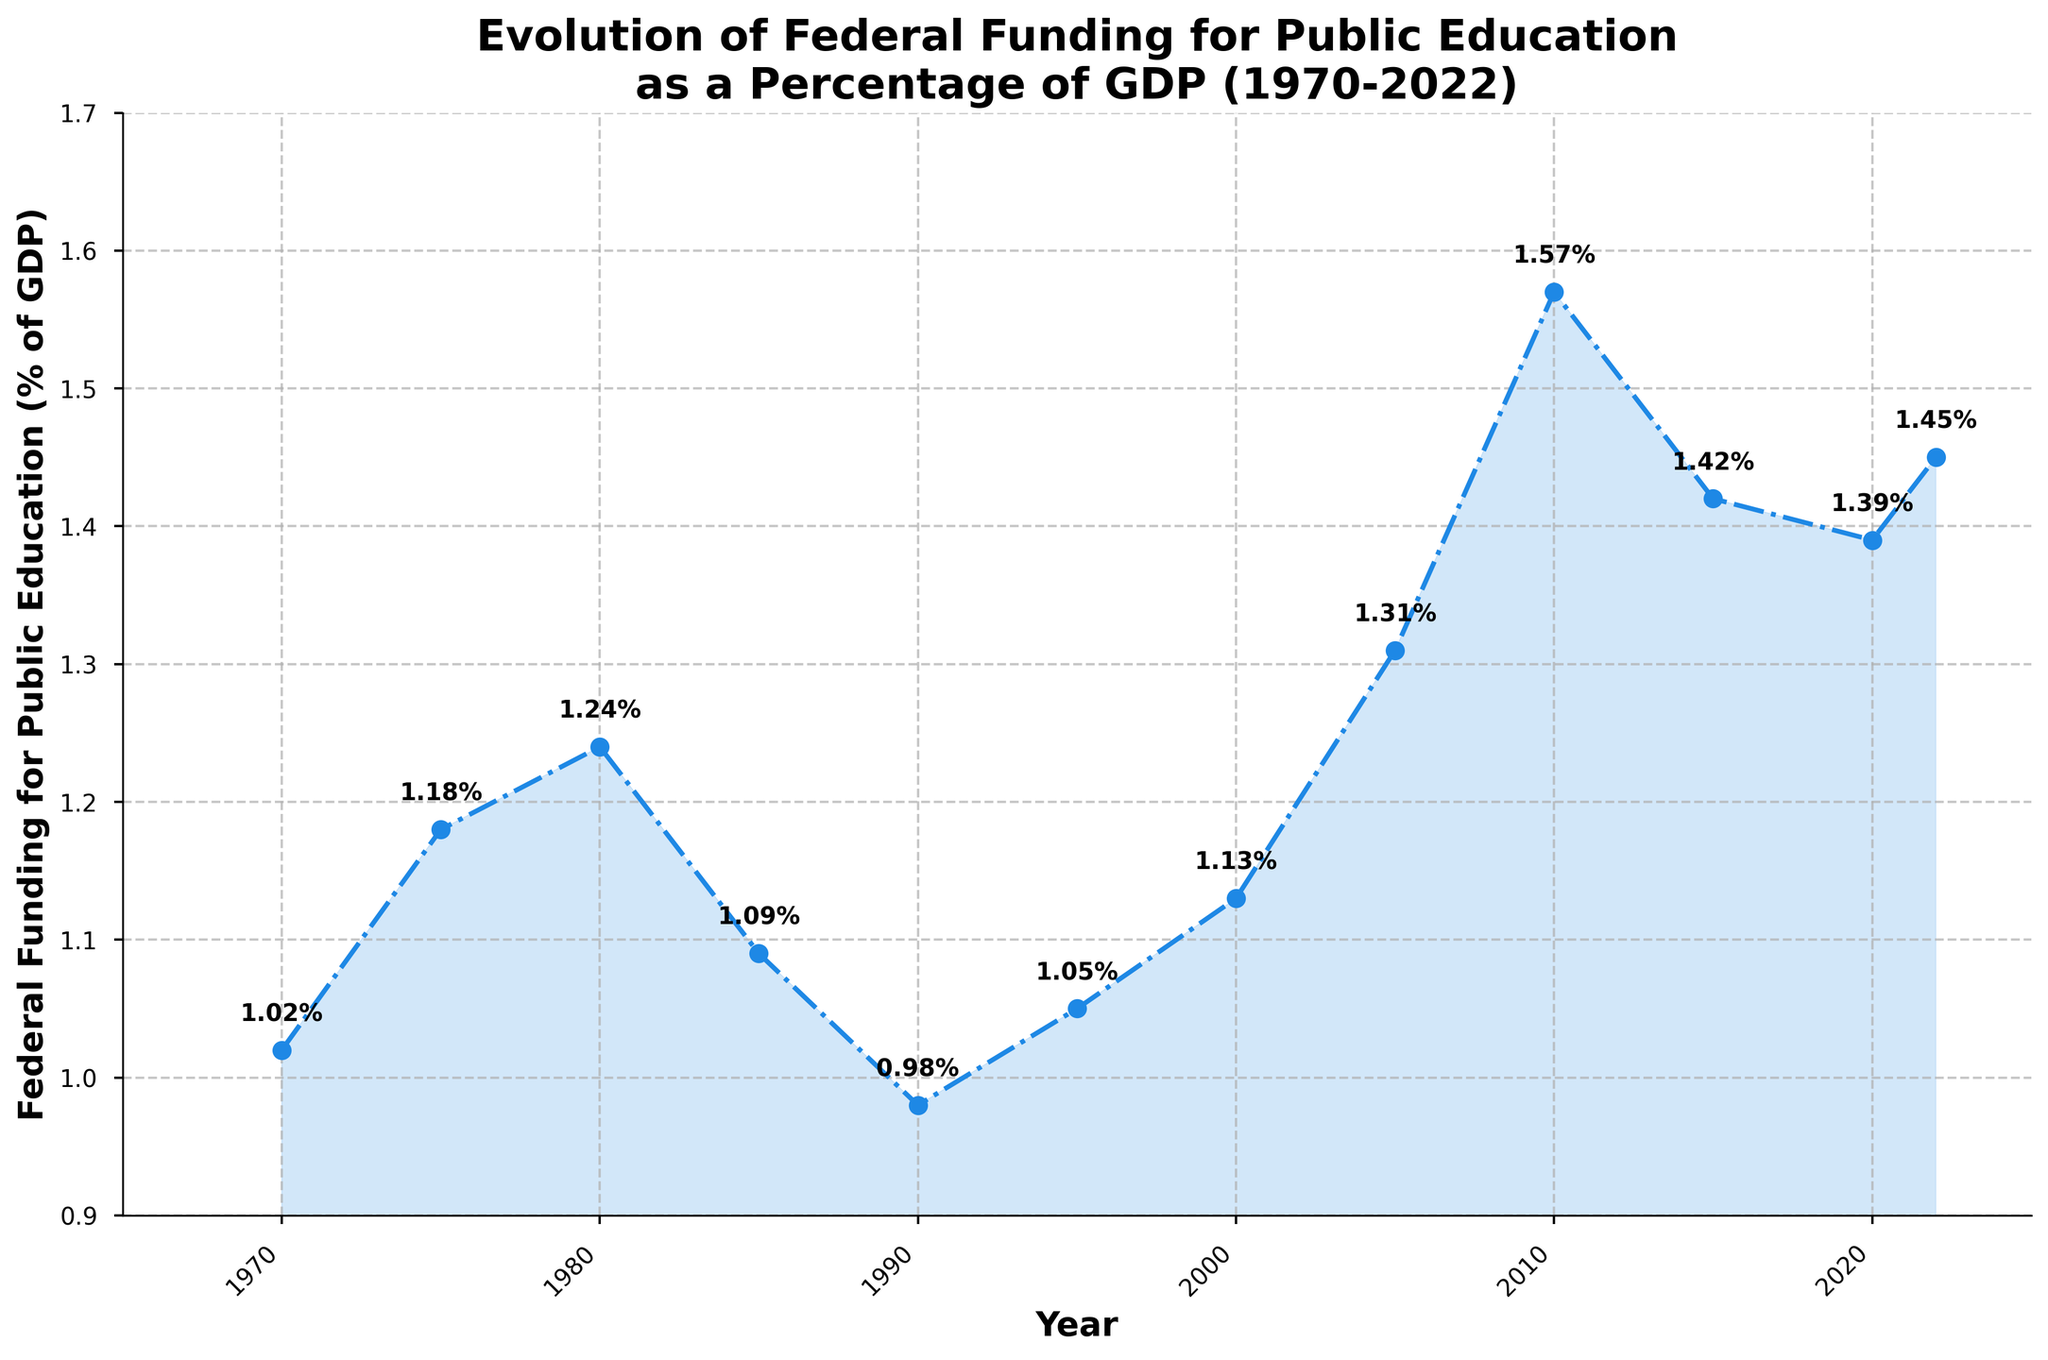What's the overall trend of federal funding for public education as a percentage of GDP from 1970 to 2022? The overall trend appears to be mixed with periods of increase and decrease. Initially, from 1970, there is an increase until 1980, followed by a decline until 1990. After that, it fluctuates with another significant increase from 2000 to 2010, then a slight decrease and modest recovery until 2022.
Answer: Mixed trend Which year marks the highest percentage of federal funding for public education? By looking at the peaks in the line chart, 2010 marks the highest percentage, where the funding is at 1.57% of GDP.
Answer: 2010 How does the federal funding percentage in 2022 compare to that in 1970? Comparing the two specific points on the chart for 1970 and 2022, 1970 had 1.02% and 2022 had 1.45%. Hence, there is an increase from 1970 to 2022.
Answer: 2022 is higher Between which consecutive years was the largest increase in federal funding percentage observed? By observing the increments between consecutive years, the largest increase is between 2005 (1.31%) and 2010 (1.57%), which is an increase of 0.26%.
Answer: 2005-2010 What is the average federal funding percentage for the years 1980, 1985, and 1990? Add the percentages for the three years: 1.24% (1980), 1.09% (1985), and 0.98% (1990). The total sum is 1.24 + 1.09 + 0.98 = 3.31. Divide by 3 to get the average: 3.31 / 3 = 1.10%.
Answer: 1.10% What was the percentage decrease in federal funding from 1980 to 1990? The percentage in 1980 was 1.24% and in 1990 was 0.98%. The decrease is 1.24 - 0.98 = 0.26%. The percentage decrease is (0.26 / 1.24) * 100 ≈ 20.97%.
Answer: 20.97% How many years did the federal funding percentage remain above 1.30%? By scanning the chart, the years 2005 (1.31%) and 2010 (1.57%) are above 1.30%. So, there are 2 years in total.
Answer: 2 years In which decade was there a consistent decline in federal funding percentage? The decline is consistent from 1980 to 1990, as the percentage fell from 1.24% in 1980 to 0.98% in 1990.
Answer: 1980s How does the funding percentage in 2020 compare to that in 2015? The percentage in 2015 is 1.42% and in 2020 it is 1.39%. Hence, the funding percentage in 2020 is lower than in 2015.
Answer: 2020 is lower 